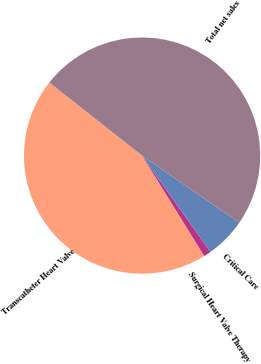<chart> <loc_0><loc_0><loc_500><loc_500><pie_chart><fcel>Transcatheter Heart Valve<fcel>Surgical Heart Valve Therapy<fcel>Critical Care<fcel>Total net sales<nl><fcel>44.44%<fcel>1.0%<fcel>5.56%<fcel>49.0%<nl></chart> 